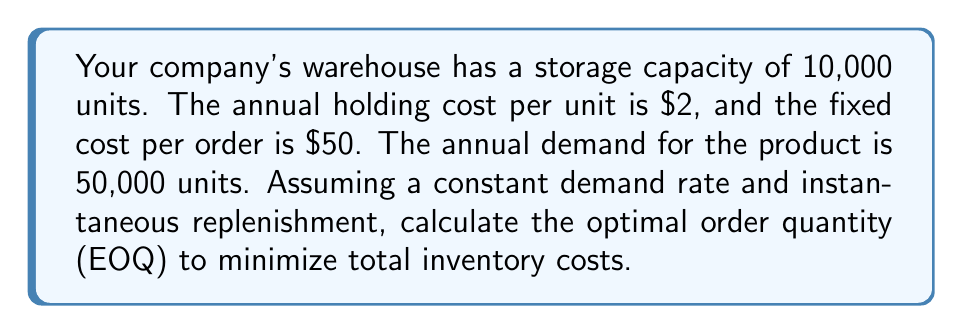Can you solve this math problem? To solve this problem, we'll use the Economic Order Quantity (EOQ) model. The steps are as follows:

1. Identify the variables:
   $D$ = Annual demand = 50,000 units
   $K$ = Fixed cost per order = $50
   $h$ = Annual holding cost per unit = $2

2. Use the EOQ formula:
   $$ EOQ = \sqrt{\frac{2KD}{h}} $$

3. Substitute the values:
   $$ EOQ = \sqrt{\frac{2 \cdot 50 \cdot 50,000}{2}} $$

4. Simplify:
   $$ EOQ = \sqrt{2,500,000} $$

5. Calculate the result:
   $$ EOQ = 1,581.14 \text{ units} $$

6. Round to the nearest whole number:
   $$ EOQ \approx 1,581 \text{ units} $$

This optimal order quantity will minimize the total inventory costs, balancing the trade-off between ordering costs and holding costs.
Answer: 1,581 units 